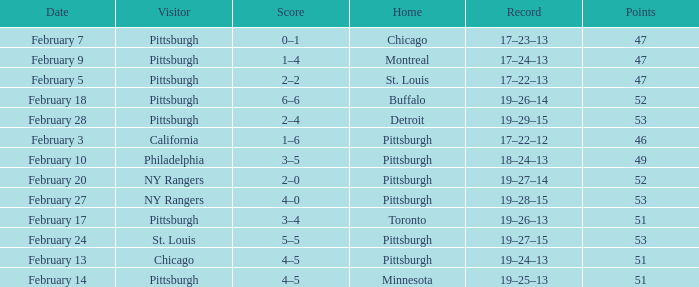Which Score has a Visitor of ny rangers, and a Record of 19–28–15? 4–0. 